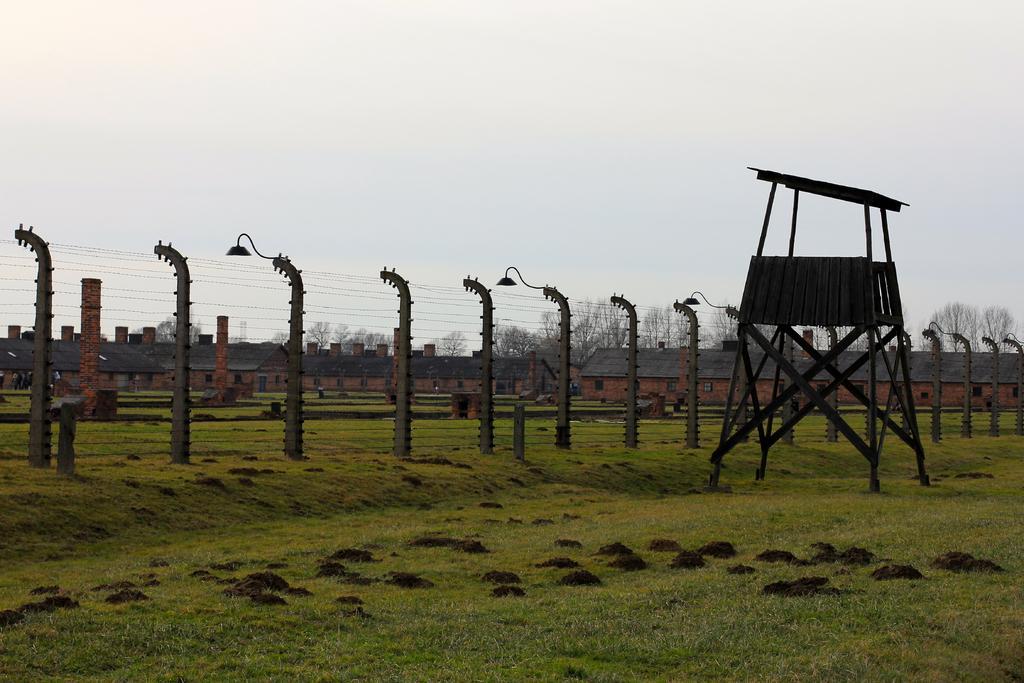How would you summarize this image in a sentence or two? On the ground there is grass. Also there is a fencing with poles. On the poles there are lights. Also there is a wooden stand. In the back there are buildings, trees and sky. 